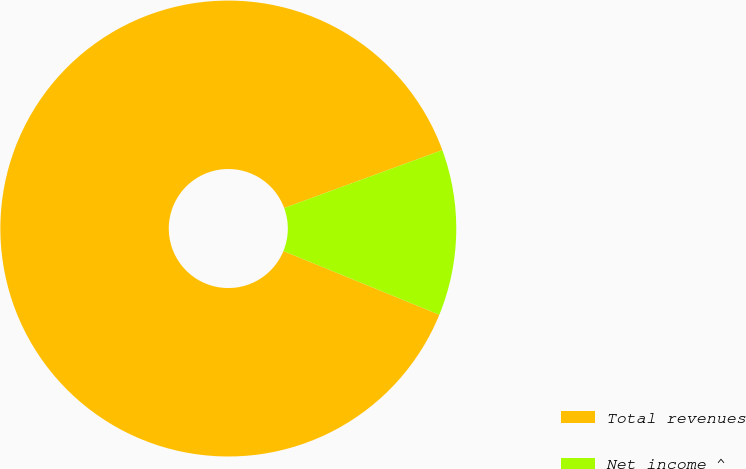Convert chart to OTSL. <chart><loc_0><loc_0><loc_500><loc_500><pie_chart><fcel>Total revenues<fcel>Net income ^<nl><fcel>88.24%<fcel>11.76%<nl></chart> 